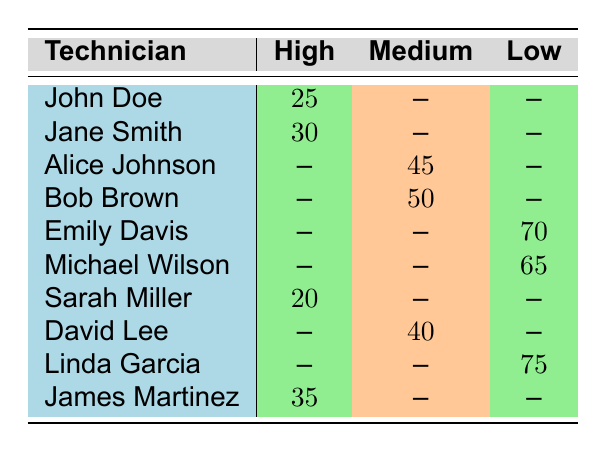What is the response time for Sarah Miller on high priority requests? The table indicates that Sarah Miller has a response time of 20 minutes for high priority requests.
Answer: 20 minutes Who has the highest response time for medium priority requests? From the table, Alice Johnson has a response time of 45 minutes and Bob Brown has 50 minutes, which is the highest for medium priority requests.
Answer: Bob Brown Is there a technician who responded to low priority requests with a time shorter than 70 minutes? Emily Davis responded with 70 minutes, and Michael Wilson responded with 65 minutes. Yes, Michael Wilson's response time is shorter.
Answer: Yes What are the average response times for high priority requests? The high priority times for technicians John Doe, Jane Smith, Sarah Miller, and James Martinez are 25, 30, 20, and 35 minutes respectively. The average is (25 + 30 + 20 + 35) / 4 = 27.5 minutes.
Answer: 27.5 minutes Which technician has the shortest response time overall? Examining all response times: 25, 30, 45, 50, 70, 65, 20, 40, 75, and 35 minutes, Sarah Miller has the shortest at 20 minutes.
Answer: Sarah Miller 